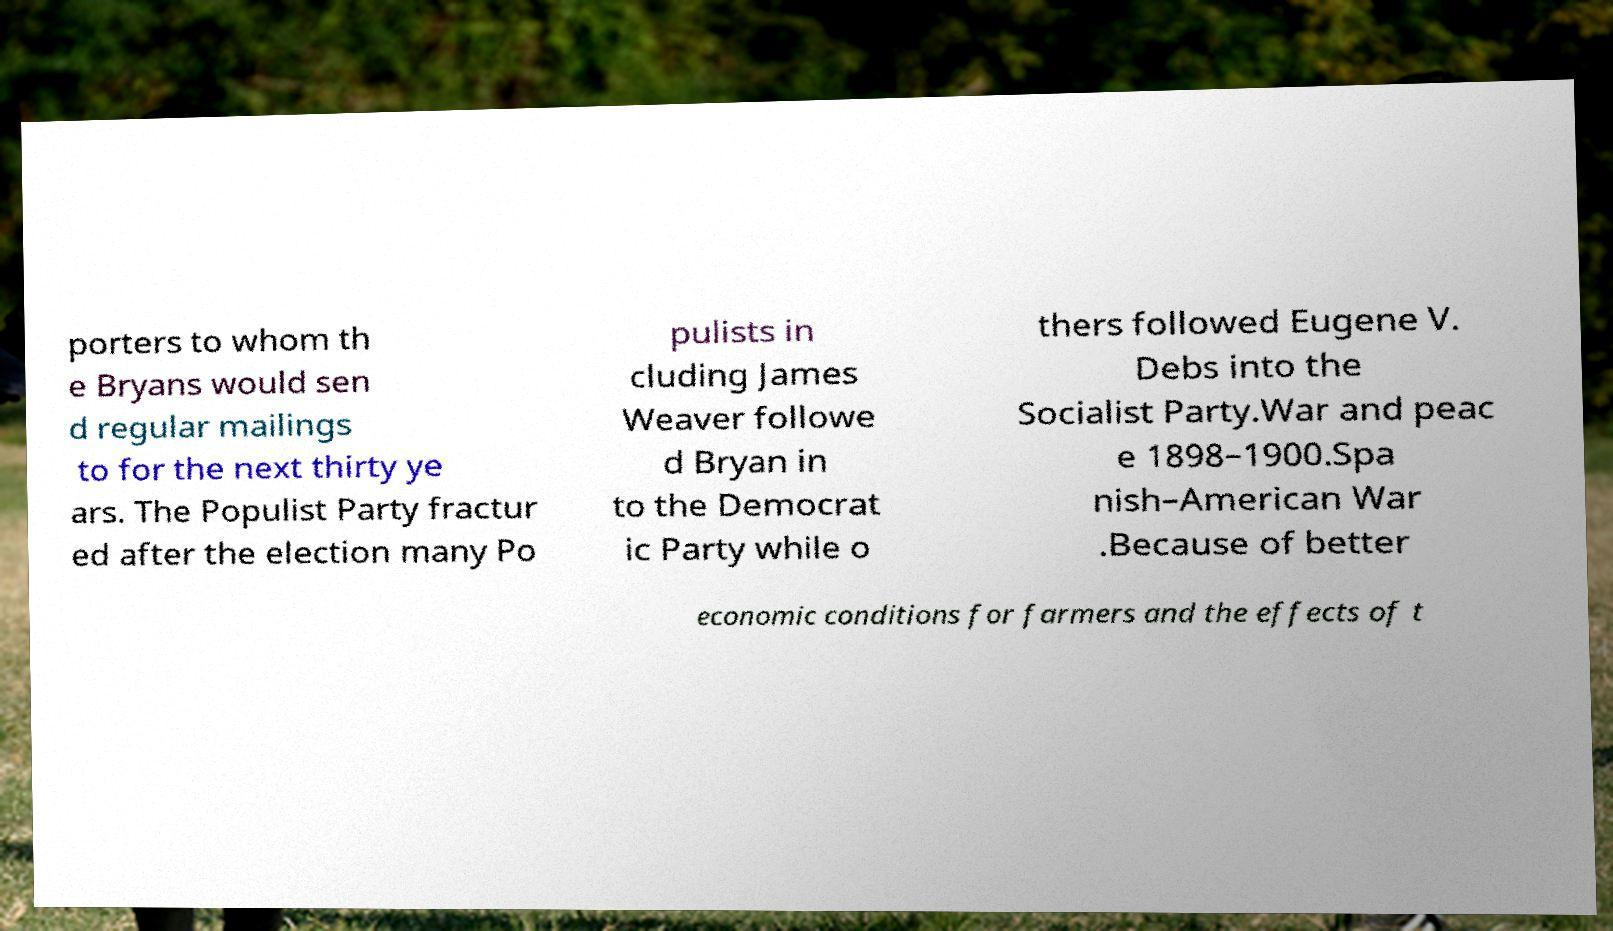I need the written content from this picture converted into text. Can you do that? porters to whom th e Bryans would sen d regular mailings to for the next thirty ye ars. The Populist Party fractur ed after the election many Po pulists in cluding James Weaver followe d Bryan in to the Democrat ic Party while o thers followed Eugene V. Debs into the Socialist Party.War and peac e 1898–1900.Spa nish–American War .Because of better economic conditions for farmers and the effects of t 